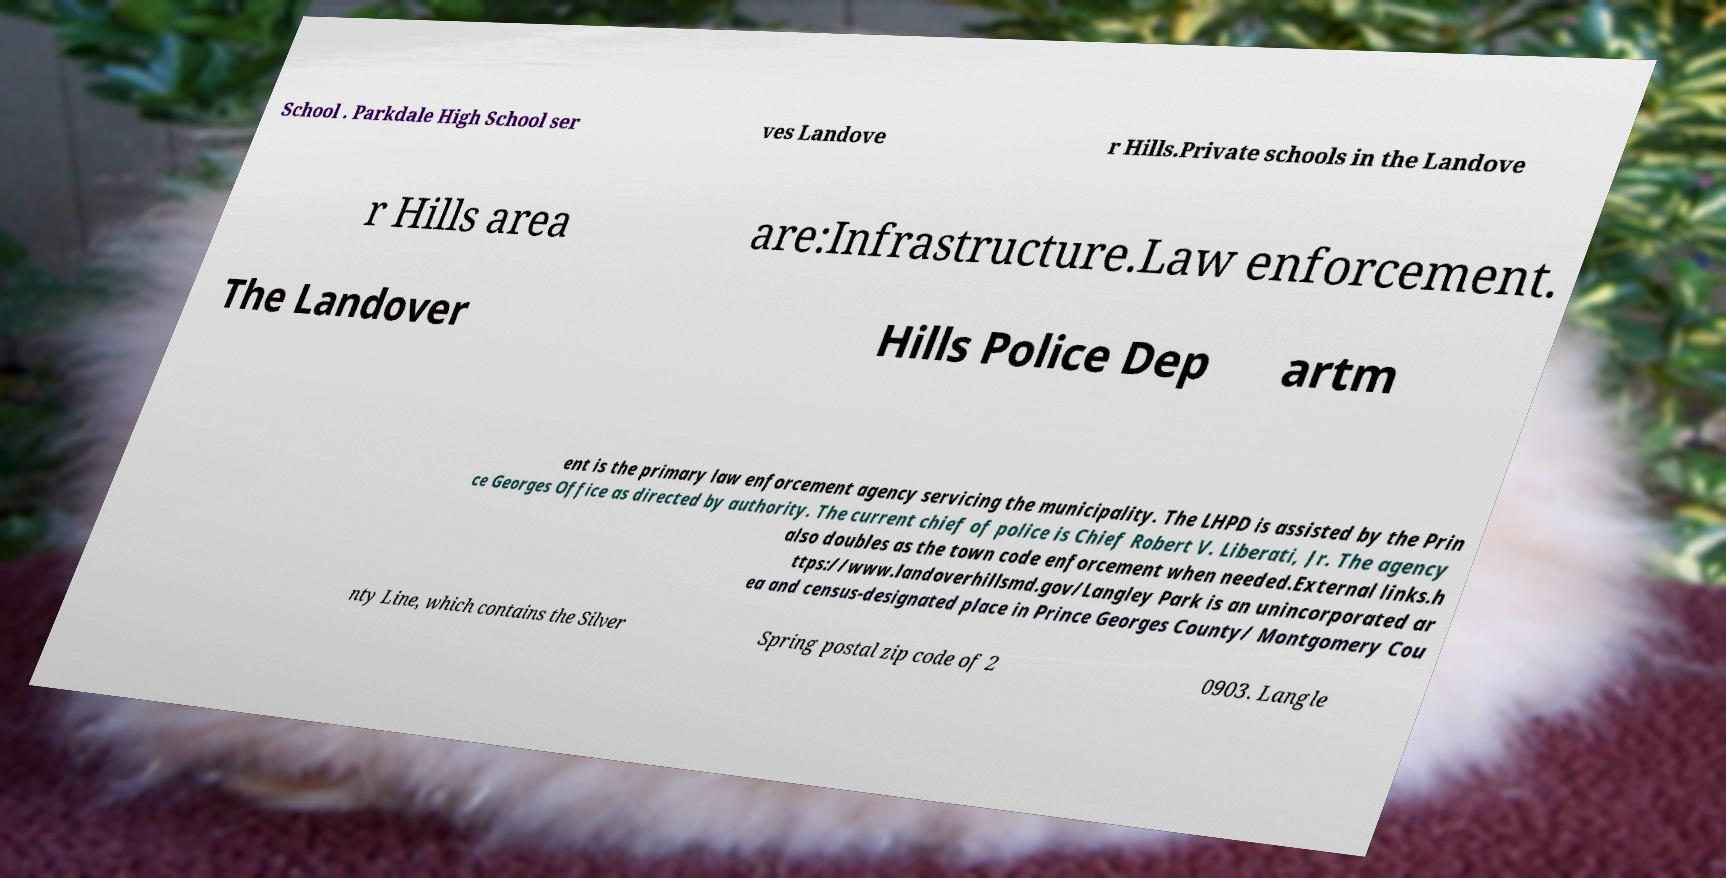Could you extract and type out the text from this image? School . Parkdale High School ser ves Landove r Hills.Private schools in the Landove r Hills area are:Infrastructure.Law enforcement. The Landover Hills Police Dep artm ent is the primary law enforcement agency servicing the municipality. The LHPD is assisted by the Prin ce Georges Office as directed by authority. The current chief of police is Chief Robert V. Liberati, Jr. The agency also doubles as the town code enforcement when needed.External links.h ttps://www.landoverhillsmd.gov/Langley Park is an unincorporated ar ea and census-designated place in Prince Georges County/ Montgomery Cou nty Line, which contains the Silver Spring postal zip code of 2 0903. Langle 